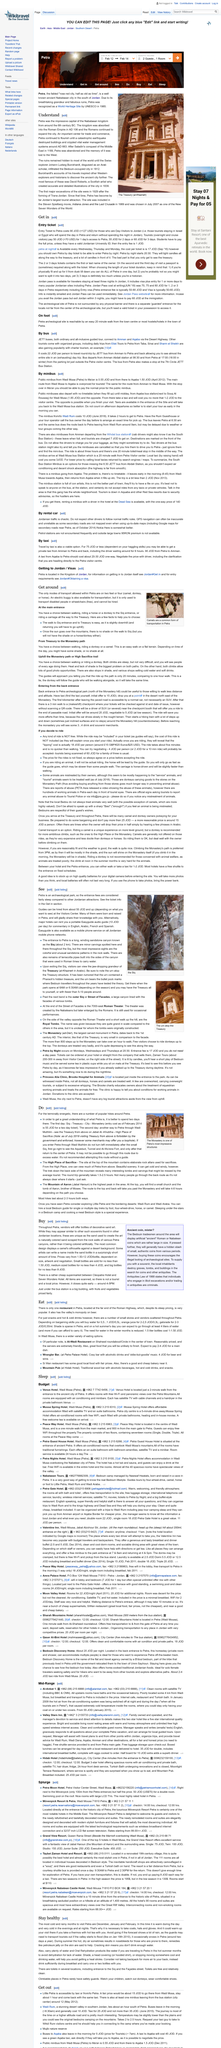Specify some key components in this picture. The animal depicted in the image is a common form of transportation in Petra and is widely used by the citizens of the city. Yes, a donkey is a mode of transport in Petra. Yes, a horse is a mode of transportation in Petra. 